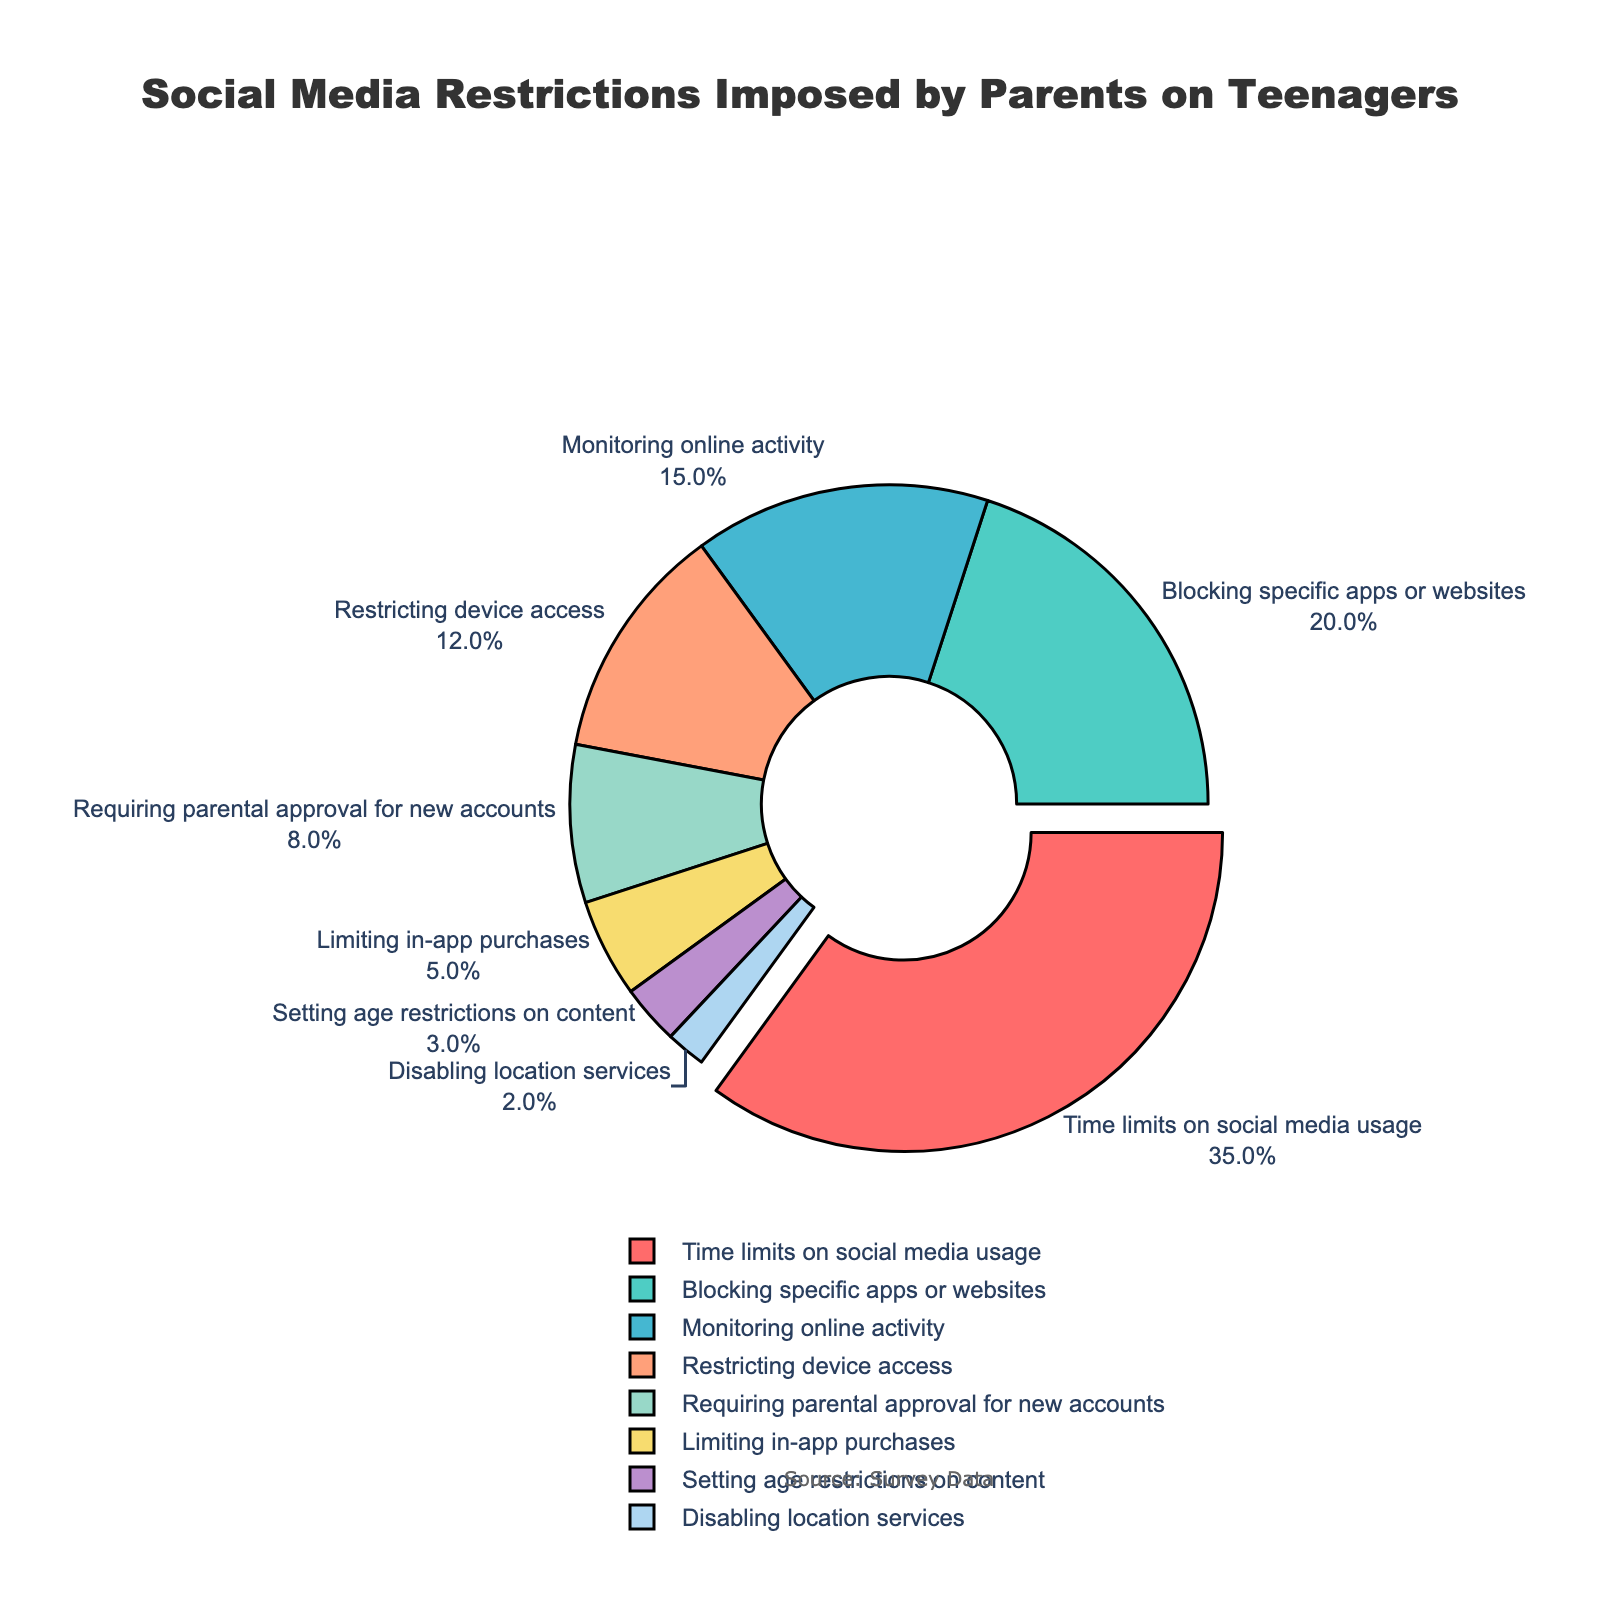What is the most common type of social media restriction imposed by parents? The size of each pie slice represents the percentage of each category. The largest slice represents the most common restriction. Time limits on social media usage constitute 35%, making it the largest slice.
Answer: Time limits on social media usage Which type of restriction is more common: Blocking specific apps or websites, or Requiring parental approval for new accounts? By comparing the percentages, Blocking specific apps or websites is represented by 20%, whereas Requiring parental approval for new accounts is 8%, so blocking specific apps or websites is more common.
Answer: Blocking specific apps or websites How much more common is Monitoring online activity than Disabling location services? Monitoring online activity is 15% and Disabling location services is 2%. The difference is 15% - 2% = 13%.
Answer: 13% Which two types of restrictions combined make up more than half of the total restrictions? The total percentage should add up to 100%. Any two categories that sum to more than 50% are more than half. Time limits on social media usage (35%) and Blocking specific apps or websites (20%) together make 35% + 20% = 55%, which is more than half.
Answer: Time limits on social media usage and Blocking specific apps or websites What is the combined percentage of all restrictions other than Time limits on social media usage? Time limits on social media usage is 35%. Subtract this from 100% to find the percentage of all other restrictions. 100% - 35% = 65%.
Answer: 65% How does the percentage of Restricting device access compare to that of Limiting in-app purchases? Restricting device access is represented by 12% and Limiting in-app purchases is 5%. 12% is more than 5%.
Answer: Restricting device access is more than Limiting in-app purchases What percentage of restrictions require parental actions such as monitoring, approval, blocking, or setting age restrictions? Monitoring online activity (15%), Requiring parental approval for new accounts (8%), Blocking specific apps or websites (20%), and Setting age restrictions on content (3%) are types involving parental actions. Sum these: 15% + 8% + 20% + 3% = 46%.
Answer: 46% Which restriction type is the least common and what percentage does it represent? The smallest slice represents the least common restriction. Disabling location services is represented by the smallest slice, which is 2%.
Answer: Disabling location services How much less common is Limiting in-app purchases compared to Time limits on social media usage? Limiting in-app purchases is 5% and Time limits on social media usage is 35%. The difference is 35% - 5% = 30%.
Answer: 30% Which color represents Blocking specific apps or websites, and what is the meaning of this restriction? Each pie slice has a unique color. Blocking specific apps or websites is represented in green. This restriction means preventing access to selected social media apps or websites.
Answer: Green; preventing access to selected apps or websites 